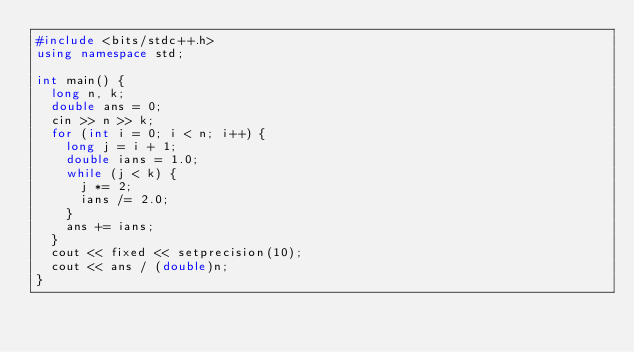<code> <loc_0><loc_0><loc_500><loc_500><_C++_>#include <bits/stdc++.h>
using namespace std;

int main() {
  long n, k;
  double ans = 0;
  cin >> n >> k;
  for (int i = 0; i < n; i++) {
    long j = i + 1;
    double ians = 1.0;
    while (j < k) {
      j *= 2;
      ians /= 2.0;
    }
    ans += ians;
  }
  cout << fixed << setprecision(10);
  cout << ans / (double)n;
}</code> 